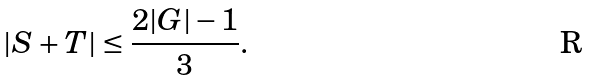Convert formula to latex. <formula><loc_0><loc_0><loc_500><loc_500>| S + T | \leq \frac { 2 | G | - 1 } { 3 } .</formula> 